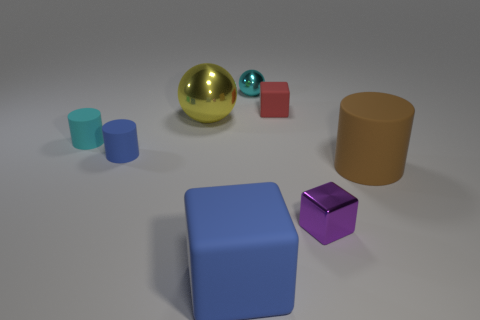Is the shape of the small cyan thing that is in front of the cyan shiny sphere the same as  the large blue rubber object?
Keep it short and to the point. No. Is the number of yellow spheres that are in front of the blue rubber cube less than the number of big cyan metallic cubes?
Provide a short and direct response. No. Are there any tiny purple things that have the same material as the yellow ball?
Your response must be concise. Yes. There is a yellow sphere that is the same size as the blue block; what material is it?
Ensure brevity in your answer.  Metal. Is the number of yellow shiny spheres right of the yellow metallic sphere less than the number of tiny spheres that are on the left side of the small cyan metallic thing?
Keep it short and to the point. No. The object that is both in front of the cyan metallic sphere and behind the big metallic object has what shape?
Your answer should be very brief. Cube. What number of other metallic objects have the same shape as the cyan shiny object?
Make the answer very short. 1. There is a red cube that is made of the same material as the tiny blue object; what is its size?
Offer a very short reply. Small. Are there more big yellow shiny objects than small things?
Provide a short and direct response. No. What color is the big thing behind the small blue cylinder?
Offer a terse response. Yellow. 